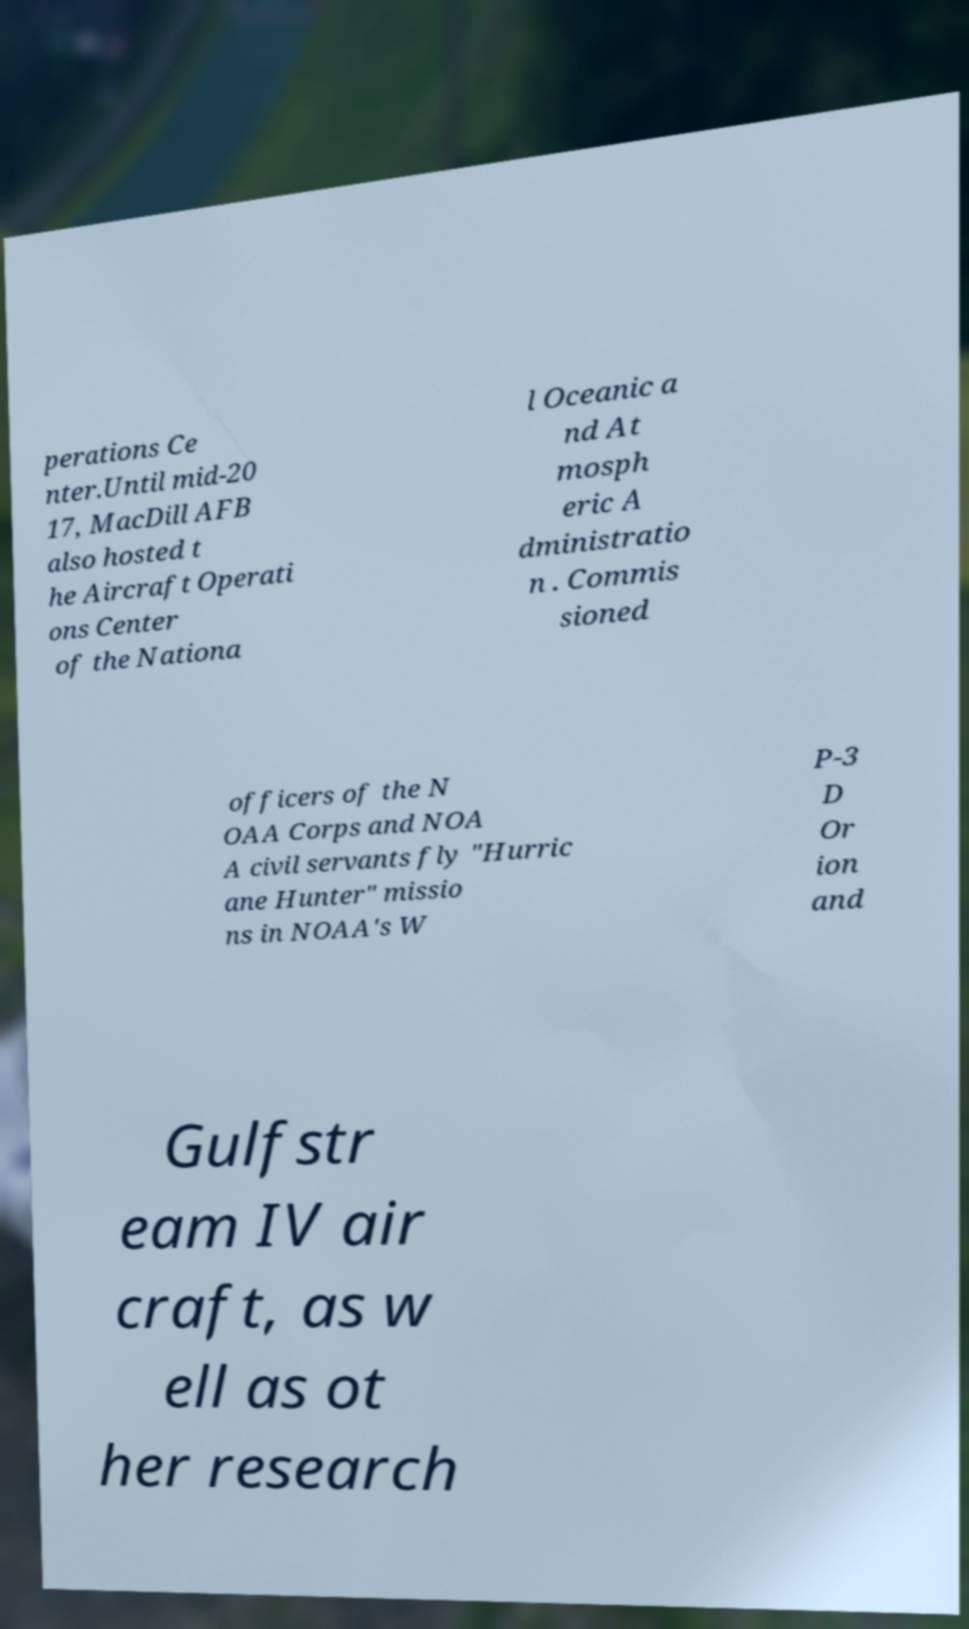Can you read and provide the text displayed in the image?This photo seems to have some interesting text. Can you extract and type it out for me? perations Ce nter.Until mid-20 17, MacDill AFB also hosted t he Aircraft Operati ons Center of the Nationa l Oceanic a nd At mosph eric A dministratio n . Commis sioned officers of the N OAA Corps and NOA A civil servants fly "Hurric ane Hunter" missio ns in NOAA's W P-3 D Or ion and Gulfstr eam IV air craft, as w ell as ot her research 